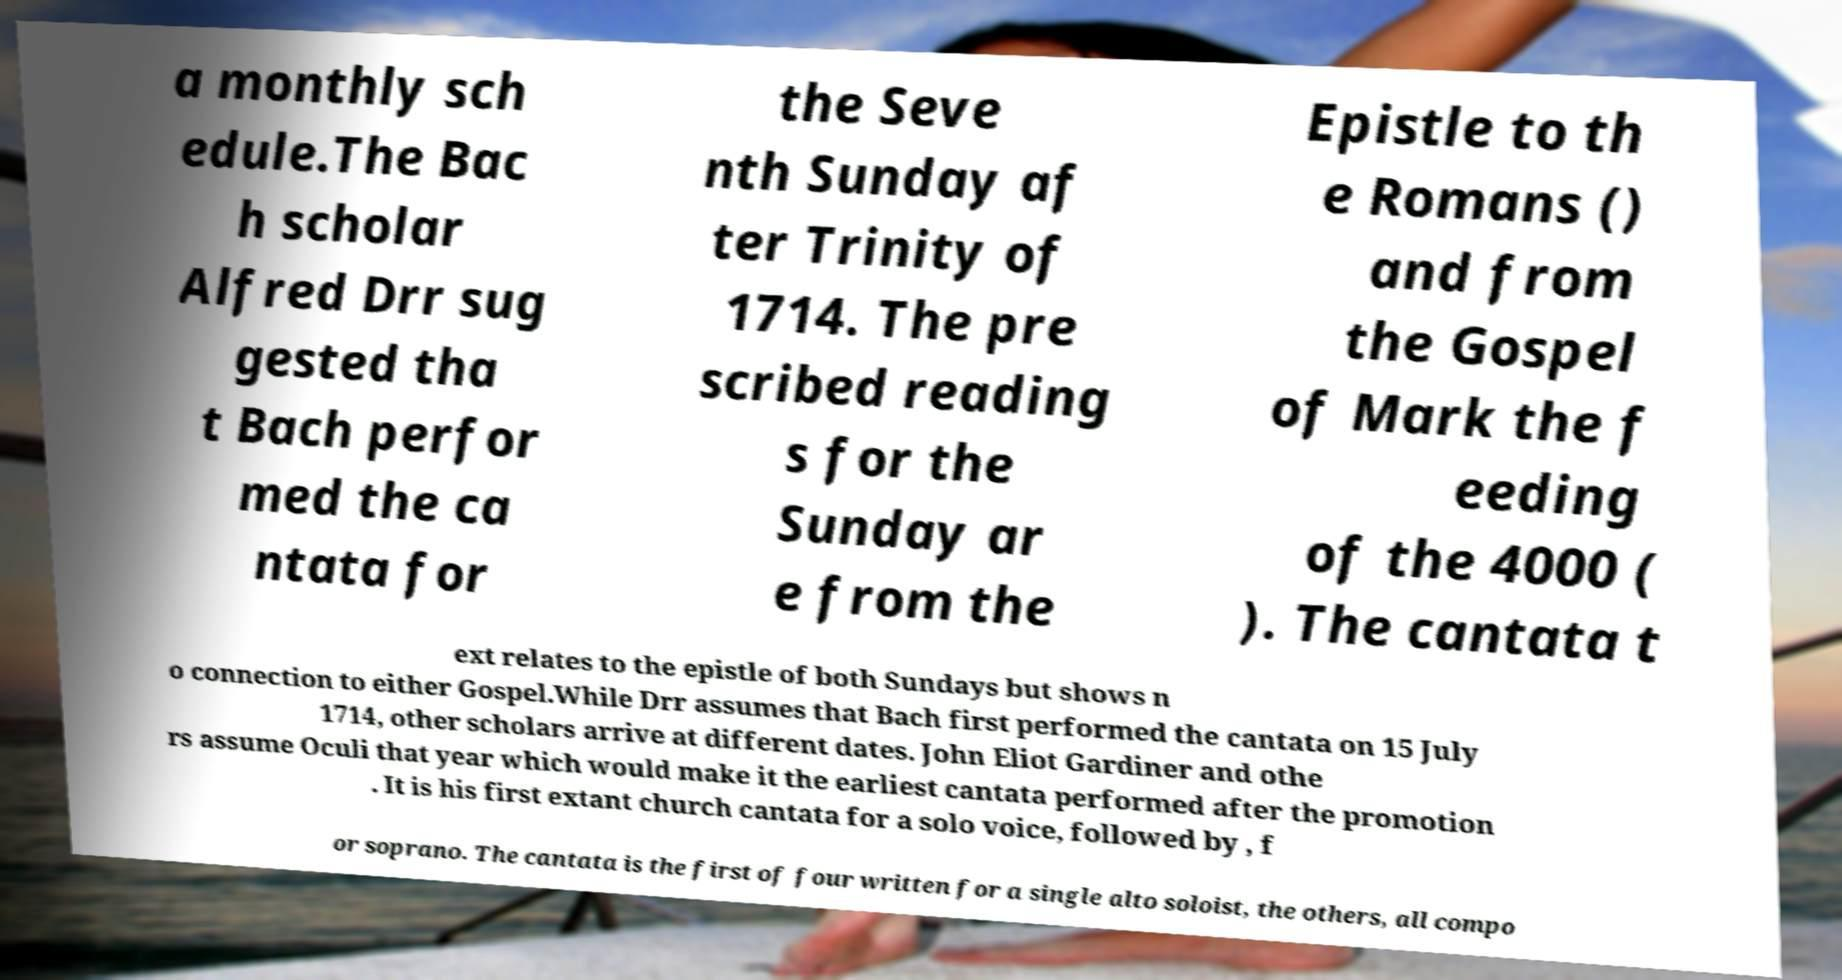Could you assist in decoding the text presented in this image and type it out clearly? a monthly sch edule.The Bac h scholar Alfred Drr sug gested tha t Bach perfor med the ca ntata for the Seve nth Sunday af ter Trinity of 1714. The pre scribed reading s for the Sunday ar e from the Epistle to th e Romans () and from the Gospel of Mark the f eeding of the 4000 ( ). The cantata t ext relates to the epistle of both Sundays but shows n o connection to either Gospel.While Drr assumes that Bach first performed the cantata on 15 July 1714, other scholars arrive at different dates. John Eliot Gardiner and othe rs assume Oculi that year which would make it the earliest cantata performed after the promotion . It is his first extant church cantata for a solo voice, followed by , f or soprano. The cantata is the first of four written for a single alto soloist, the others, all compo 